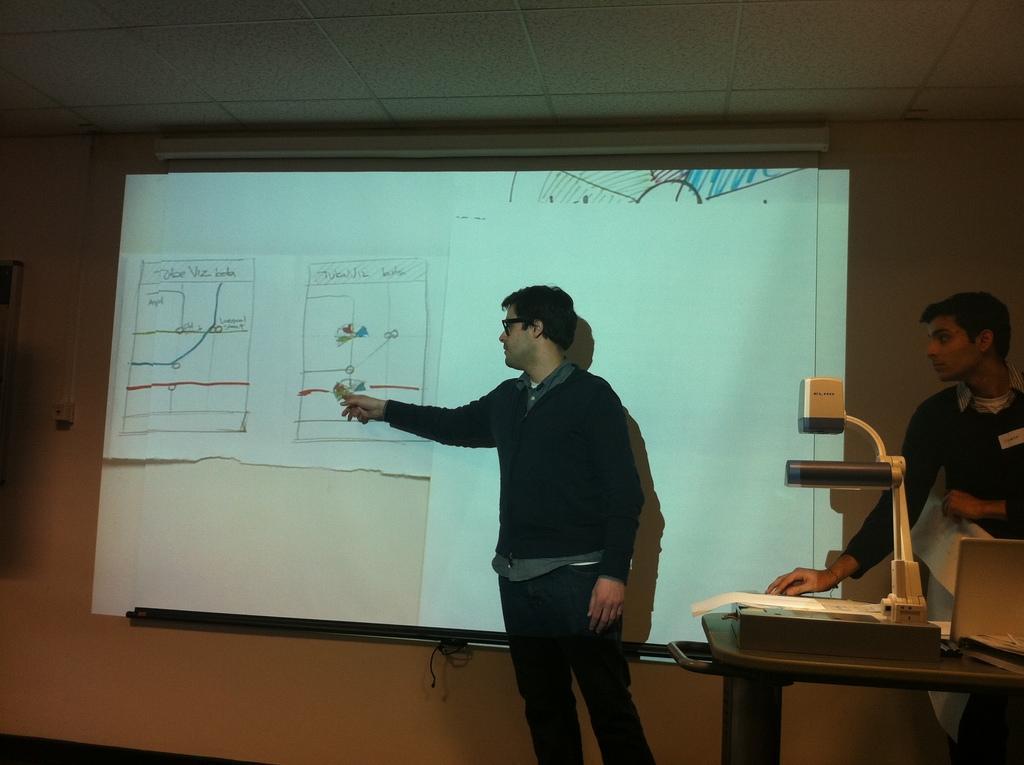Please provide a concise description of this image. In the center of the image there is a person standing at the wall. On the wall we can see charts. On the right side of the image we can see table, lights and person. 